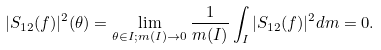Convert formula to latex. <formula><loc_0><loc_0><loc_500><loc_500>| S _ { 1 2 } ( f ) | ^ { 2 } ( \theta ) = \lim _ { \theta \in I ; m ( I ) \rightarrow 0 } \frac { 1 } { m ( I ) } \int _ { I } | S _ { 1 2 } ( f ) | ^ { 2 } d m = 0 .</formula> 